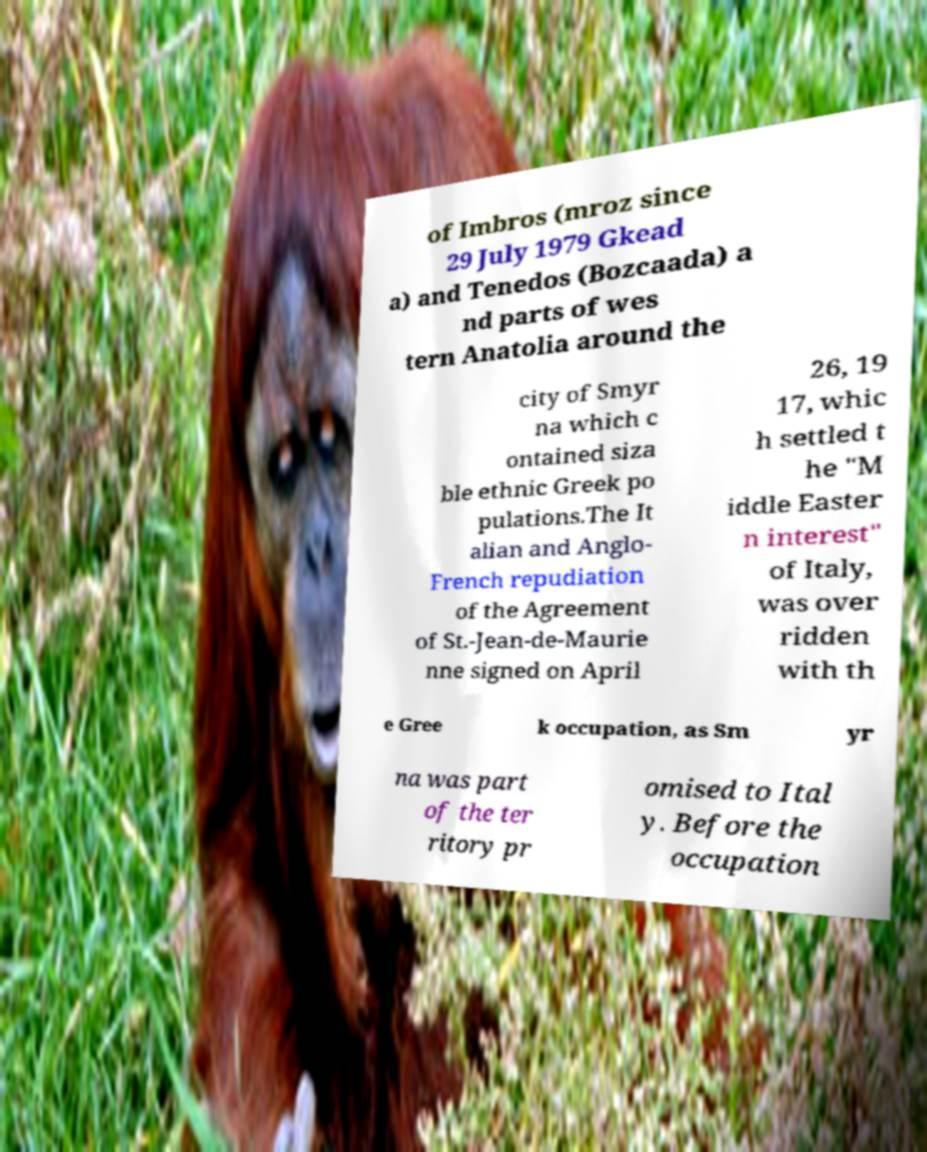Could you assist in decoding the text presented in this image and type it out clearly? of Imbros (mroz since 29 July 1979 Gkead a) and Tenedos (Bozcaada) a nd parts of wes tern Anatolia around the city of Smyr na which c ontained siza ble ethnic Greek po pulations.The It alian and Anglo- French repudiation of the Agreement of St.-Jean-de-Maurie nne signed on April 26, 19 17, whic h settled t he "M iddle Easter n interest" of Italy, was over ridden with th e Gree k occupation, as Sm yr na was part of the ter ritory pr omised to Ital y. Before the occupation 